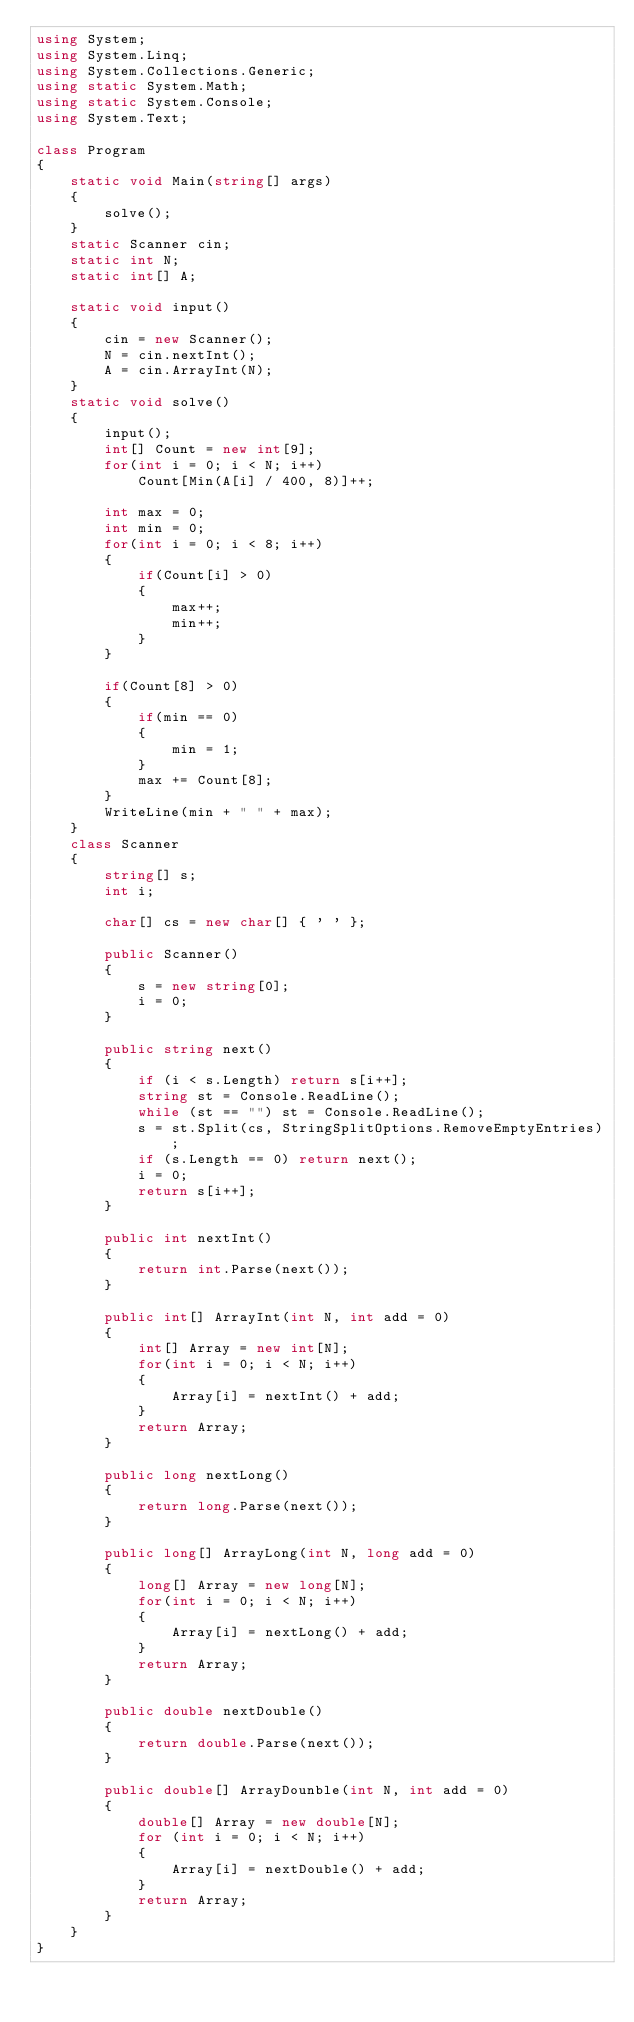<code> <loc_0><loc_0><loc_500><loc_500><_C#_>using System;
using System.Linq;
using System.Collections.Generic;
using static System.Math;
using static System.Console;
using System.Text;

class Program
{
    static void Main(string[] args)
    {
        solve();
    }
    static Scanner cin;
    static int N;
    static int[] A;

    static void input()
    {
        cin = new Scanner();
        N = cin.nextInt();
        A = cin.ArrayInt(N);
    }
    static void solve()
    {
        input();
        int[] Count = new int[9];
        for(int i = 0; i < N; i++)
            Count[Min(A[i] / 400, 8)]++;

        int max = 0;
        int min = 0;
        for(int i = 0; i < 8; i++)
        {
            if(Count[i] > 0)
            {
                max++;
                min++;
            }
        }

        if(Count[8] > 0)
        {
            if(min == 0)
            {
                min = 1;
            }
            max += Count[8];
        }
        WriteLine(min + " " + max);
    }
    class Scanner
    {
        string[] s;
        int i;

        char[] cs = new char[] { ' ' };

        public Scanner()
        {
            s = new string[0];
            i = 0;
        }
        
        public string next()
        {
            if (i < s.Length) return s[i++];
            string st = Console.ReadLine();
            while (st == "") st = Console.ReadLine();
            s = st.Split(cs, StringSplitOptions.RemoveEmptyEntries);
            if (s.Length == 0) return next();
            i = 0;
            return s[i++];
        }

        public int nextInt()
        {
            return int.Parse(next());
        }

        public int[] ArrayInt(int N, int add = 0)
        {
            int[] Array = new int[N];
            for(int i = 0; i < N; i++)
            {
                Array[i] = nextInt() + add;
            }
            return Array;
        }

        public long nextLong()
        {
            return long.Parse(next());
        }

        public long[] ArrayLong(int N, long add = 0)
        {
            long[] Array = new long[N];
            for(int i = 0; i < N; i++)
            {
                Array[i] = nextLong() + add;
            }
            return Array;
        }

        public double nextDouble()
        {
            return double.Parse(next());
        }

        public double[] ArrayDounble(int N, int add = 0)
        {
            double[] Array = new double[N];
            for (int i = 0; i < N; i++)
            {
                Array[i] = nextDouble() + add;
            }
            return Array;
        }
    }
}
</code> 